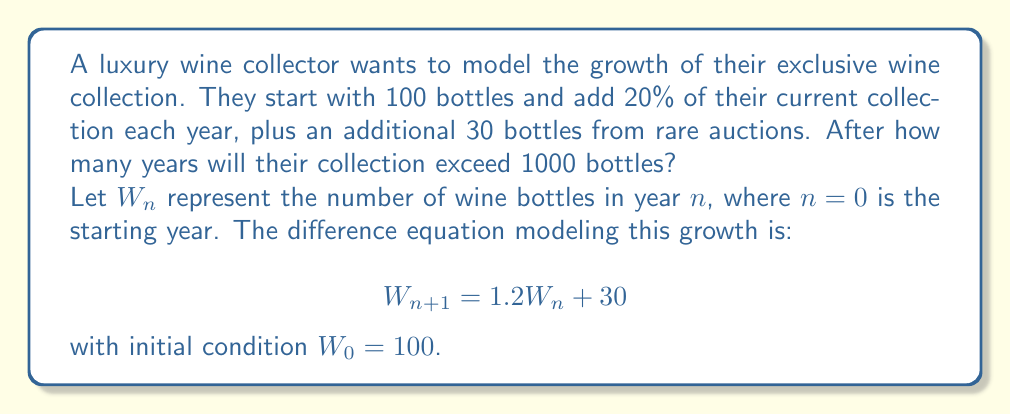Give your solution to this math problem. To solve this problem, we need to iterate the difference equation until we exceed 1000 bottles:

1) Start with $W_0 = 100$

2) Calculate subsequent years:
   $W_1 = 1.2(100) + 30 = 150$
   $W_2 = 1.2(150) + 30 = 210$
   $W_3 = 1.2(210) + 30 = 282$
   $W_4 = 1.2(282) + 30 = 368.4$
   $W_5 = 1.2(368.4) + 30 = 472.08$
   $W_6 = 1.2(472.08) + 30 = 596.496$
   $W_7 = 1.2(596.496) + 30 = 745.7952$
   $W_8 = 1.2(745.7952) + 30 = 924.95424$
   $W_9 = 1.2(924.95424) + 30 = 1139.945088$

3) We see that $W_9$ is the first value to exceed 1000 bottles.

Therefore, it will take 9 years for the collection to exceed 1000 bottles.
Answer: 9 years 